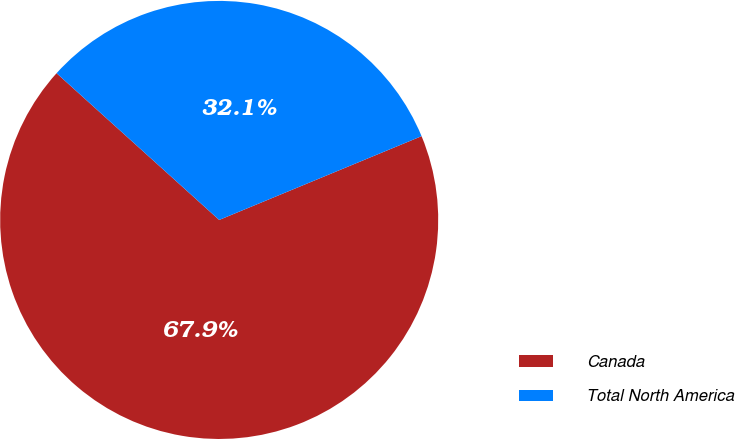<chart> <loc_0><loc_0><loc_500><loc_500><pie_chart><fcel>Canada<fcel>Total North America<nl><fcel>67.93%<fcel>32.07%<nl></chart> 